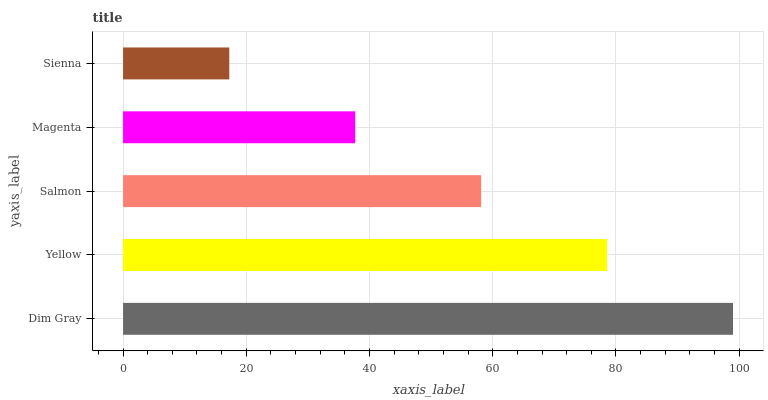Is Sienna the minimum?
Answer yes or no. Yes. Is Dim Gray the maximum?
Answer yes or no. Yes. Is Yellow the minimum?
Answer yes or no. No. Is Yellow the maximum?
Answer yes or no. No. Is Dim Gray greater than Yellow?
Answer yes or no. Yes. Is Yellow less than Dim Gray?
Answer yes or no. Yes. Is Yellow greater than Dim Gray?
Answer yes or no. No. Is Dim Gray less than Yellow?
Answer yes or no. No. Is Salmon the high median?
Answer yes or no. Yes. Is Salmon the low median?
Answer yes or no. Yes. Is Dim Gray the high median?
Answer yes or no. No. Is Sienna the low median?
Answer yes or no. No. 